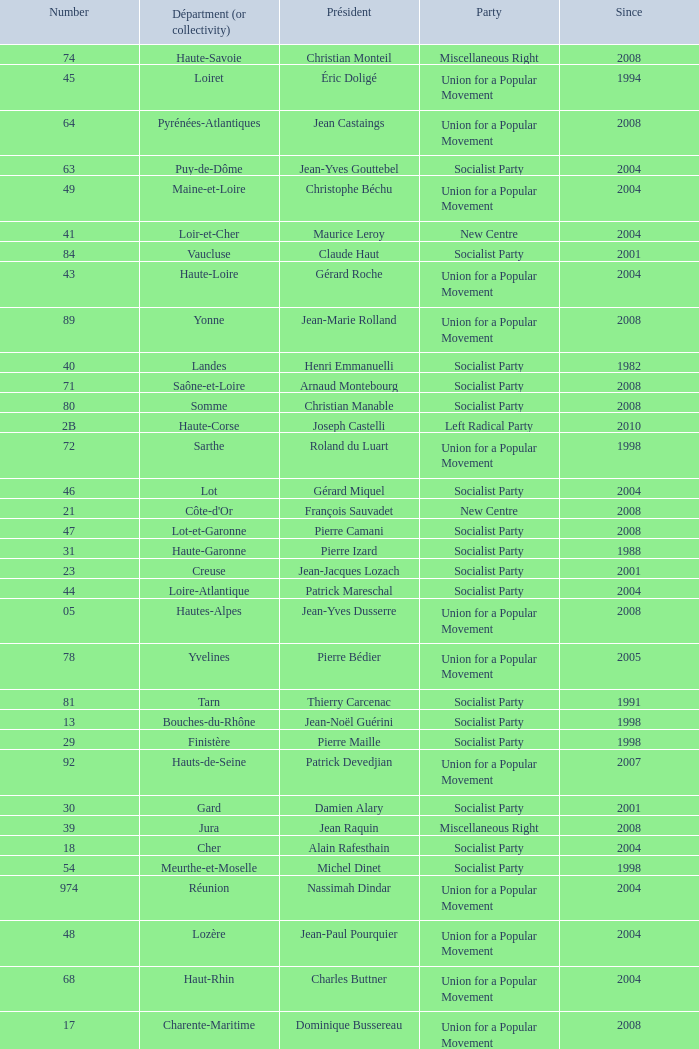Since 2008, which section has guy-dominique kennel as its head? Bas-Rhin. 